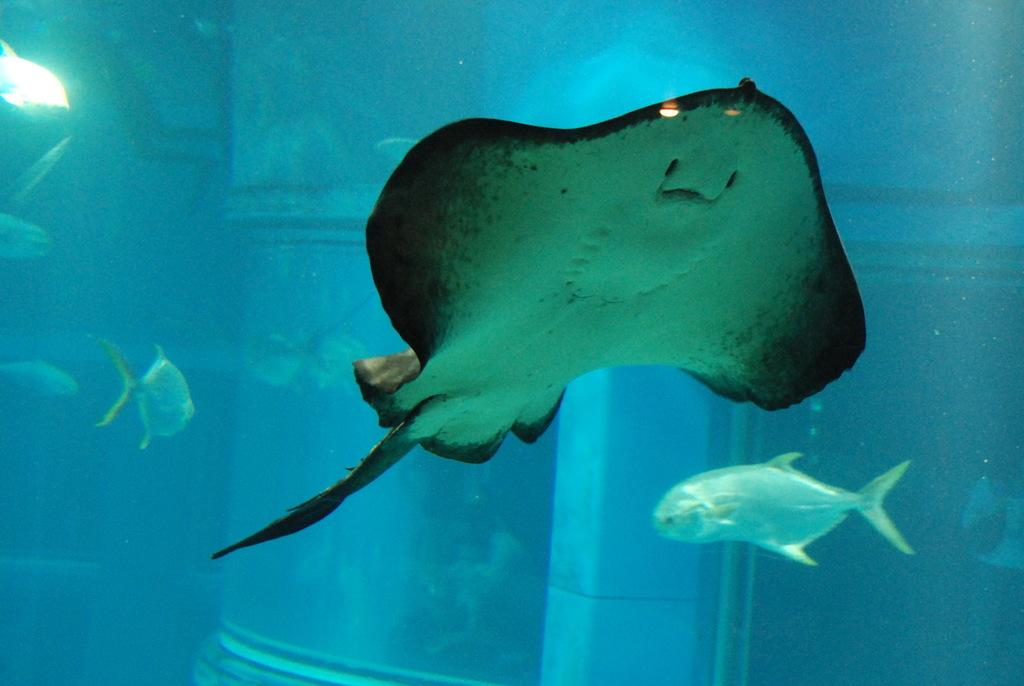What type of animals can be seen in the image? There are fishes in the image. Where are the fishes located? The fishes are in an aquarium. What type of stone is used to decorate the history of the vase in the image? There is no stone, history, or vase present in the image; it features fishes in an aquarium. 